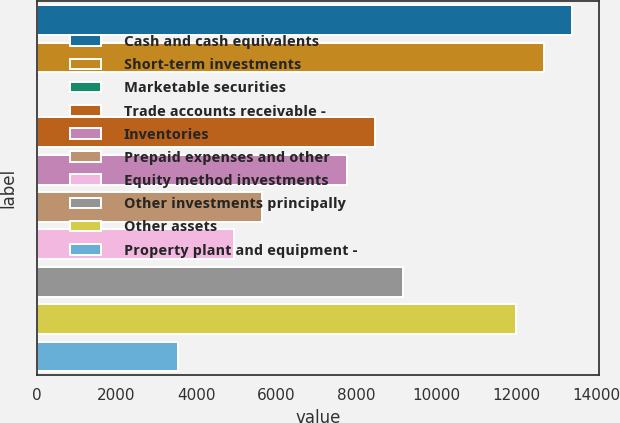Convert chart. <chart><loc_0><loc_0><loc_500><loc_500><bar_chart><fcel>Cash and cash equivalents<fcel>Short-term investments<fcel>Marketable securities<fcel>Trade accounts receivable -<fcel>Inventories<fcel>Prepaid expenses and other<fcel>Equity method investments<fcel>Other investments principally<fcel>Other assets<fcel>Property plant and equipment -<nl><fcel>13395.3<fcel>12690.6<fcel>6<fcel>8462.4<fcel>7757.7<fcel>5643.6<fcel>4938.9<fcel>9167.1<fcel>11985.9<fcel>3529.5<nl></chart> 